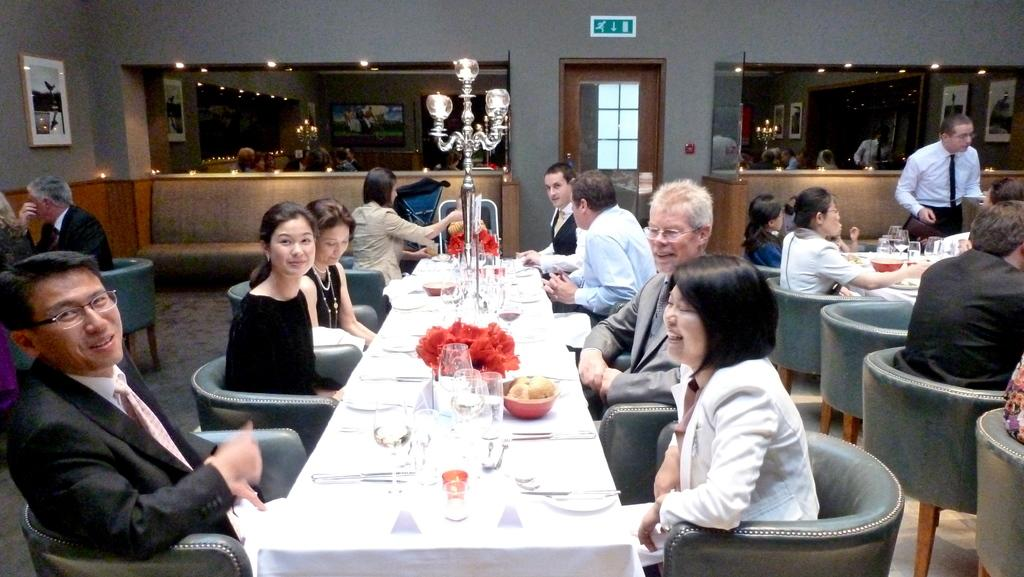What are the people in the image doing? The people in the image are sitting on chairs. What is in front of the chairs? There is a dining table in front of the chairs. What can be seen on the table? There are plates, knives, and forks on the table. What type of coast can be seen in the image? There is no coast visible in the image; it features people sitting at a dining table. What kind of meeting is taking place in the image? There is no meeting depicted in the image; it shows people sitting at a dining table. 